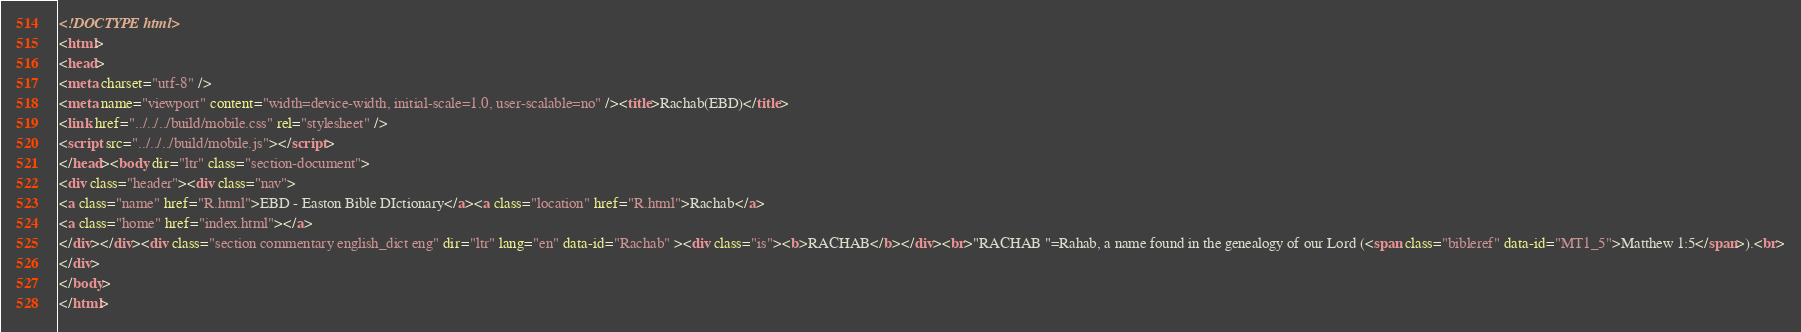<code> <loc_0><loc_0><loc_500><loc_500><_HTML_><!DOCTYPE html>
<html>
<head>
<meta charset="utf-8" />
<meta name="viewport" content="width=device-width, initial-scale=1.0, user-scalable=no" /><title>Rachab(EBD)</title>
<link href="../../../build/mobile.css" rel="stylesheet" />
<script src="../../../build/mobile.js"></script>
</head><body dir="ltr" class="section-document">
<div class="header"><div class="nav">
<a class="name" href="R.html">EBD - Easton Bible DIctionary</a><a class="location" href="R.html">Rachab</a>
<a class="home" href="index.html"></a>
</div></div><div class="section commentary english_dict eng" dir="ltr" lang="en" data-id="Rachab" ><div class="is"><b>RACHAB</b></div><br>"RACHAB "=Rahab, a name found in the genealogy of our Lord (<span class="bibleref" data-id="MT1_5">Matthew 1:5</span>).<br>
</div>
</body>
</html>
</code> 